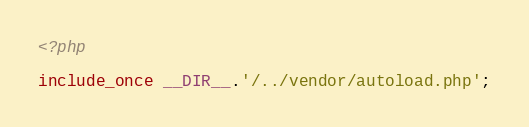<code> <loc_0><loc_0><loc_500><loc_500><_PHP_><?php

include_once __DIR__.'/../vendor/autoload.php';
</code> 